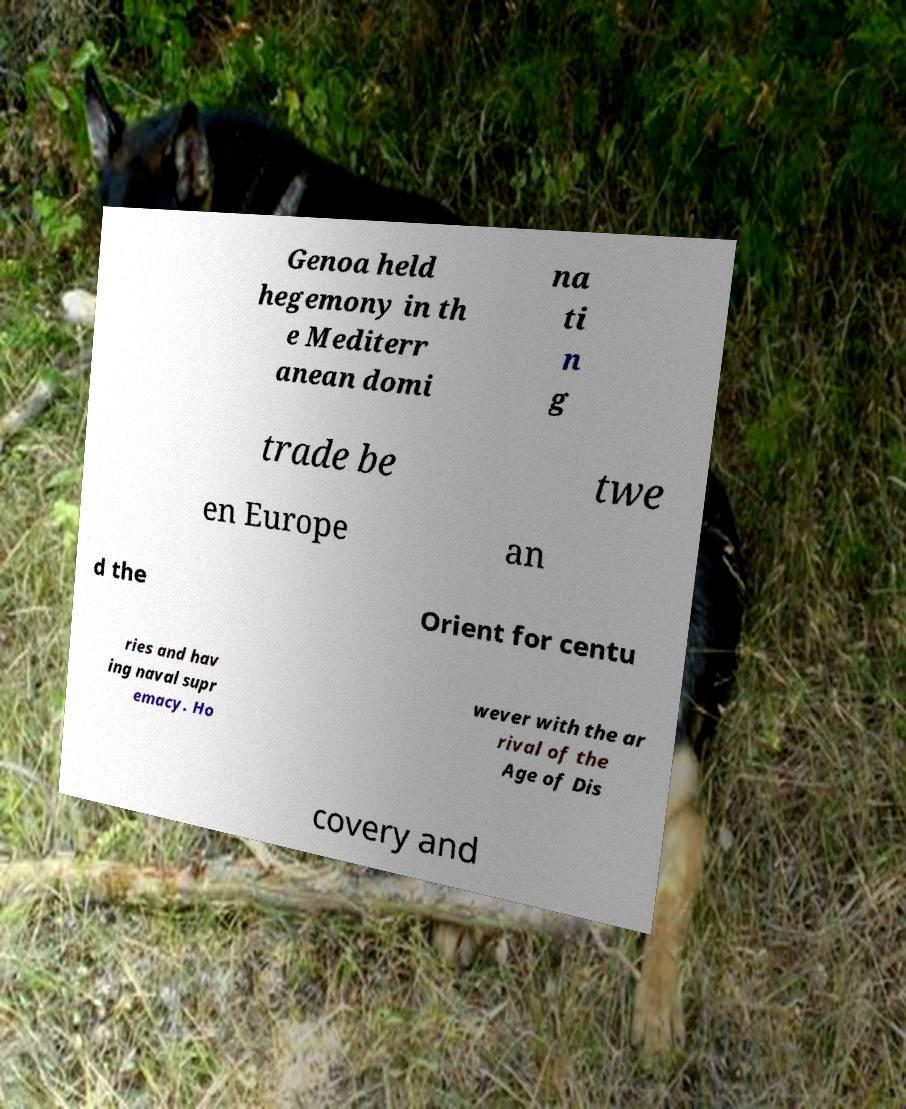Can you accurately transcribe the text from the provided image for me? Genoa held hegemony in th e Mediterr anean domi na ti n g trade be twe en Europe an d the Orient for centu ries and hav ing naval supr emacy. Ho wever with the ar rival of the Age of Dis covery and 